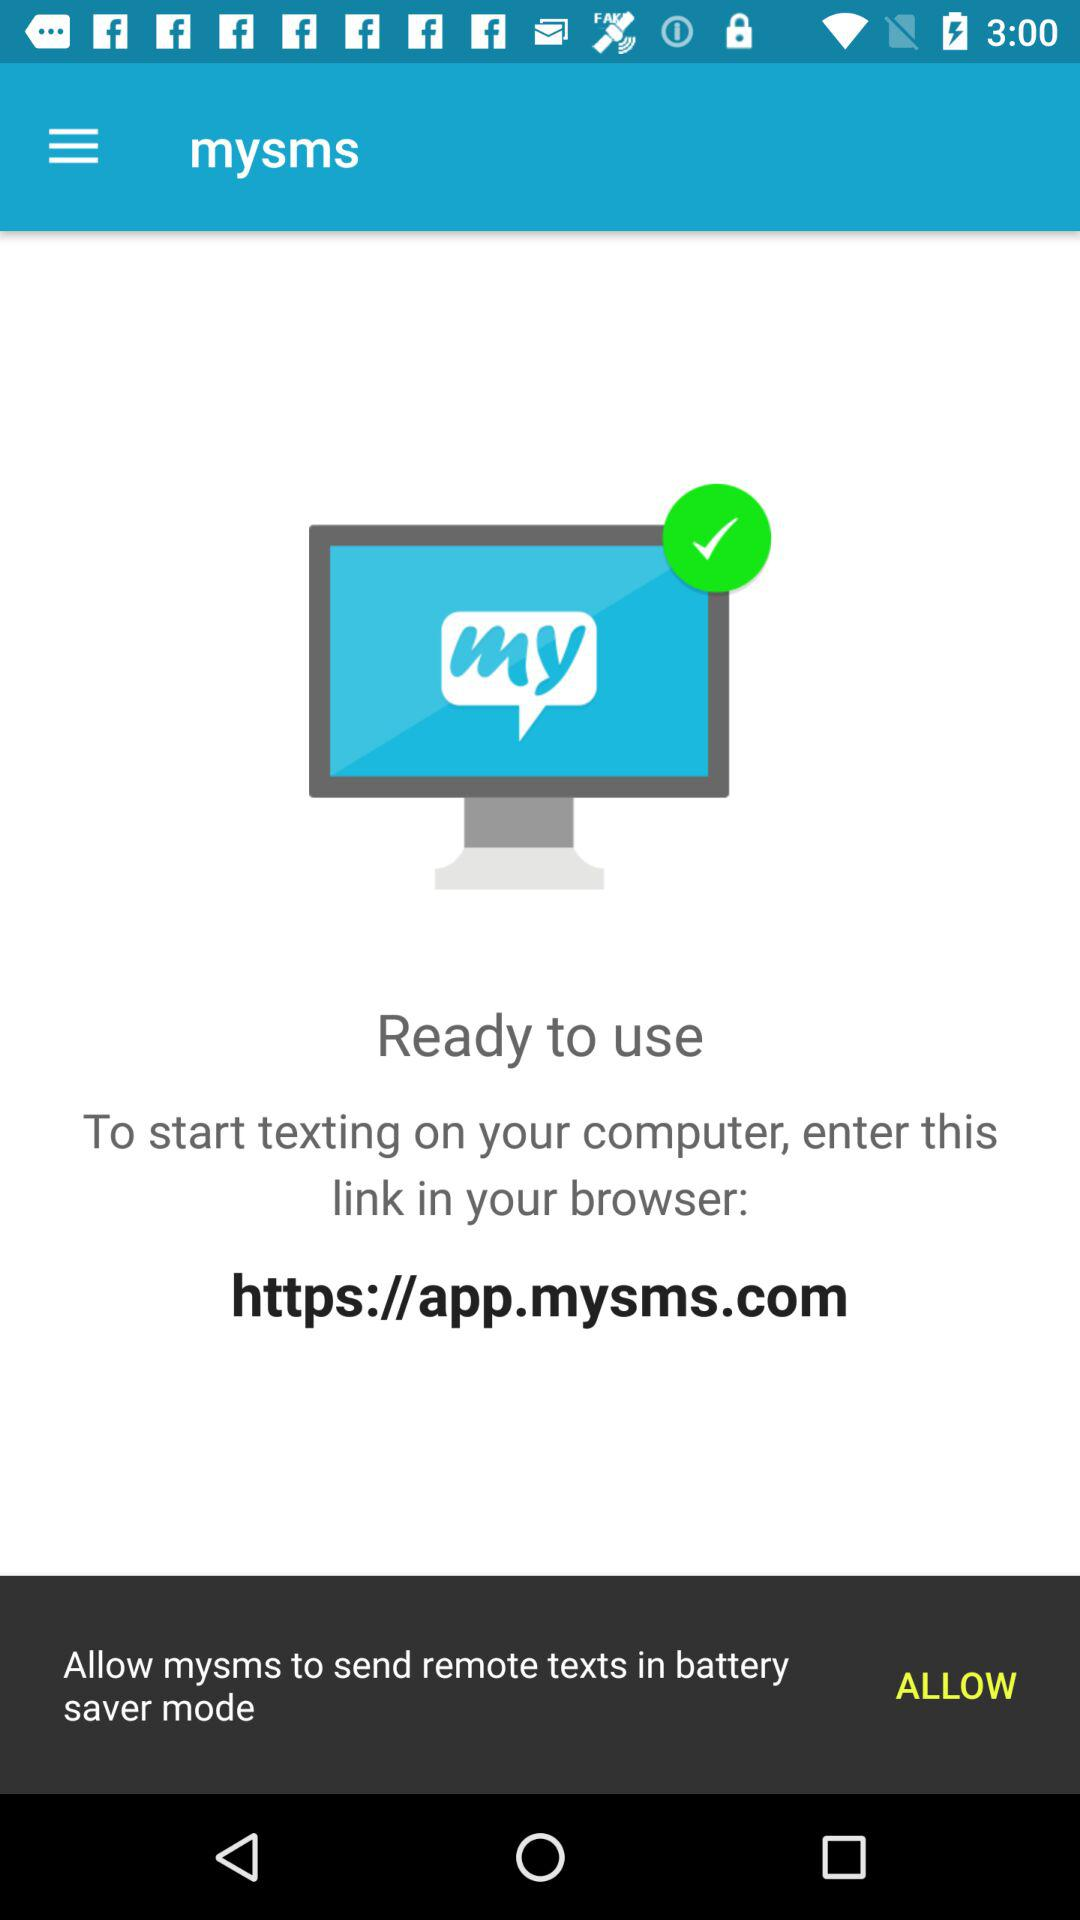What is the URL for the mysms? The URL is https://app.mysms.com. 